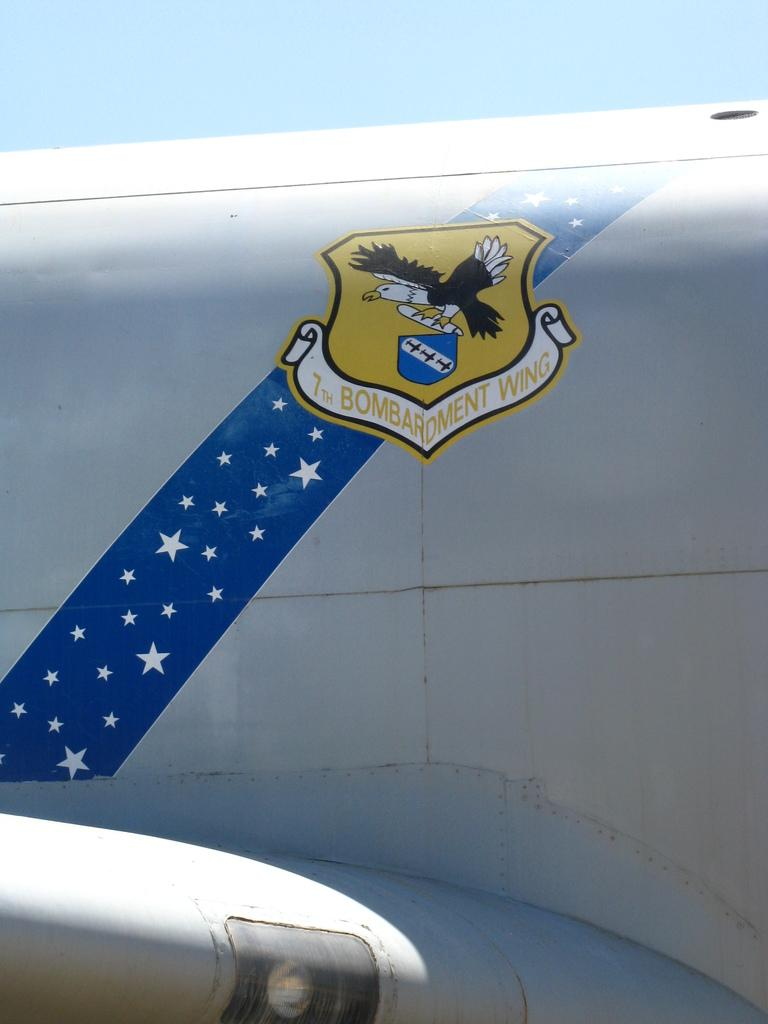Provide a one-sentence caption for the provided image. The outside of an airplane with a logo of an eagle with the saying 7th Bombardment Wings and a long blue strips with starts on the side of the airplane. 